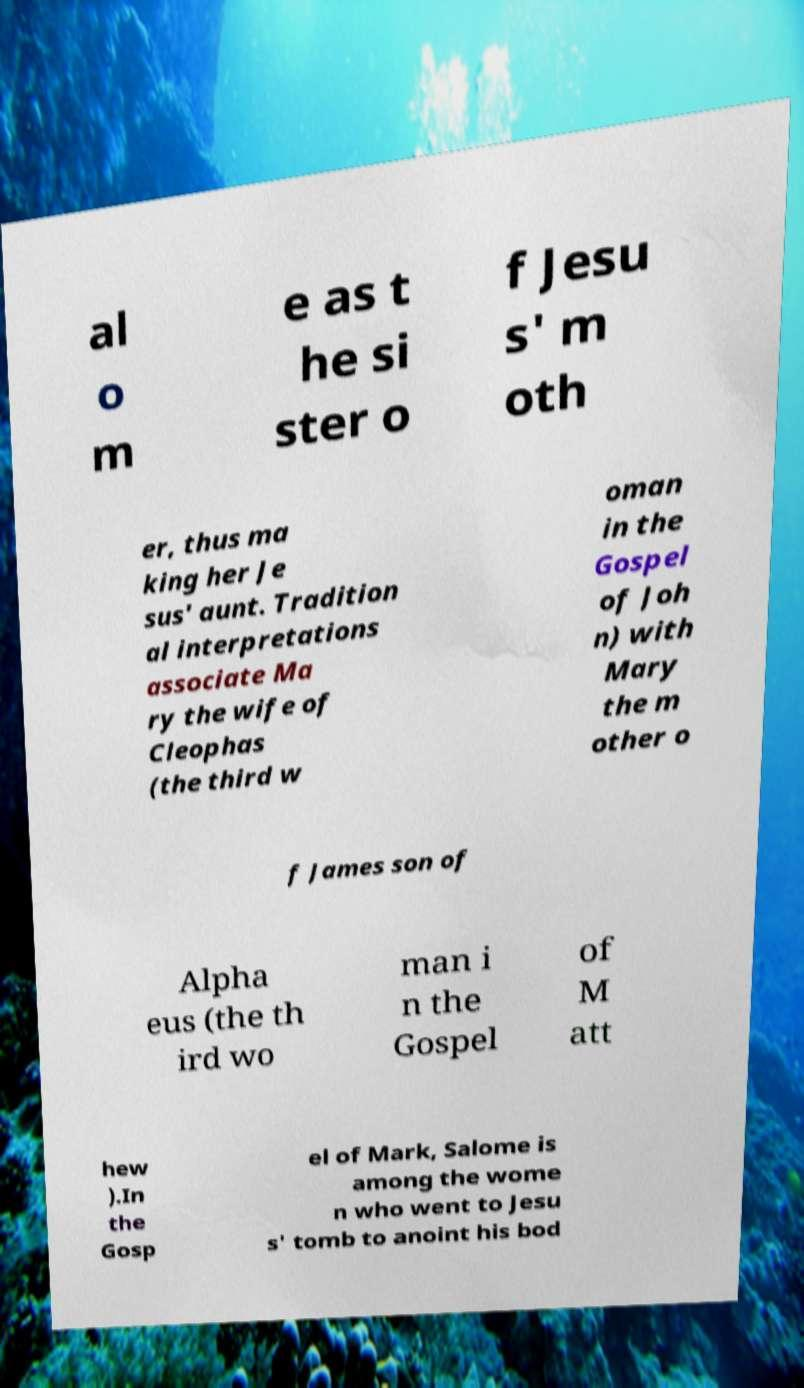Please identify and transcribe the text found in this image. al o m e as t he si ster o f Jesu s' m oth er, thus ma king her Je sus' aunt. Tradition al interpretations associate Ma ry the wife of Cleophas (the third w oman in the Gospel of Joh n) with Mary the m other o f James son of Alpha eus (the th ird wo man i n the Gospel of M att hew ).In the Gosp el of Mark, Salome is among the wome n who went to Jesu s' tomb to anoint his bod 